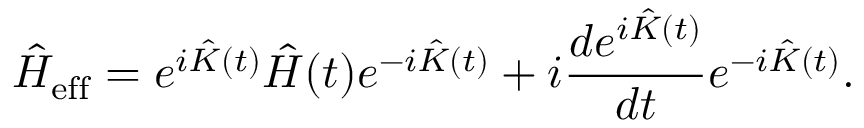<formula> <loc_0><loc_0><loc_500><loc_500>\hat { H } _ { e f f } = e ^ { i \hat { K } ( t ) } \hat { H } ( t ) e ^ { - i \hat { K } ( t ) } + i \frac { d e ^ { i \hat { K } ( t ) } } { d t } e ^ { - i \hat { K } ( t ) } .</formula> 